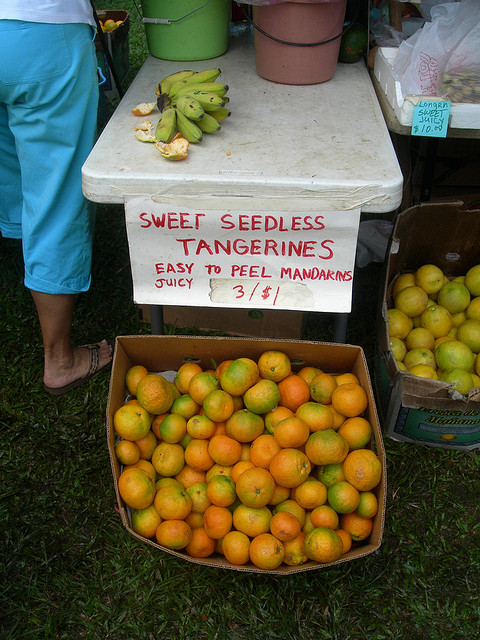Please extract the text content from this image. SWEET SEEDLESS TANGERINES EASY TO 10.00 JUICY SWEET 3 MANDAKINS PEEL JUICY 